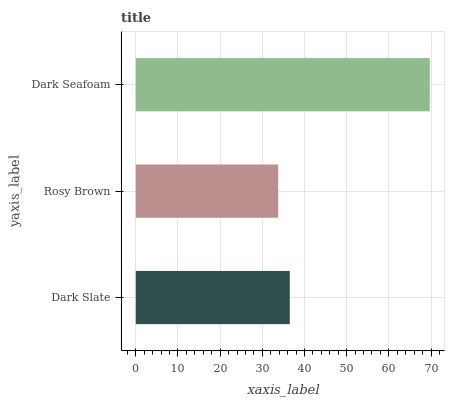Is Rosy Brown the minimum?
Answer yes or no. Yes. Is Dark Seafoam the maximum?
Answer yes or no. Yes. Is Dark Seafoam the minimum?
Answer yes or no. No. Is Rosy Brown the maximum?
Answer yes or no. No. Is Dark Seafoam greater than Rosy Brown?
Answer yes or no. Yes. Is Rosy Brown less than Dark Seafoam?
Answer yes or no. Yes. Is Rosy Brown greater than Dark Seafoam?
Answer yes or no. No. Is Dark Seafoam less than Rosy Brown?
Answer yes or no. No. Is Dark Slate the high median?
Answer yes or no. Yes. Is Dark Slate the low median?
Answer yes or no. Yes. Is Rosy Brown the high median?
Answer yes or no. No. Is Rosy Brown the low median?
Answer yes or no. No. 